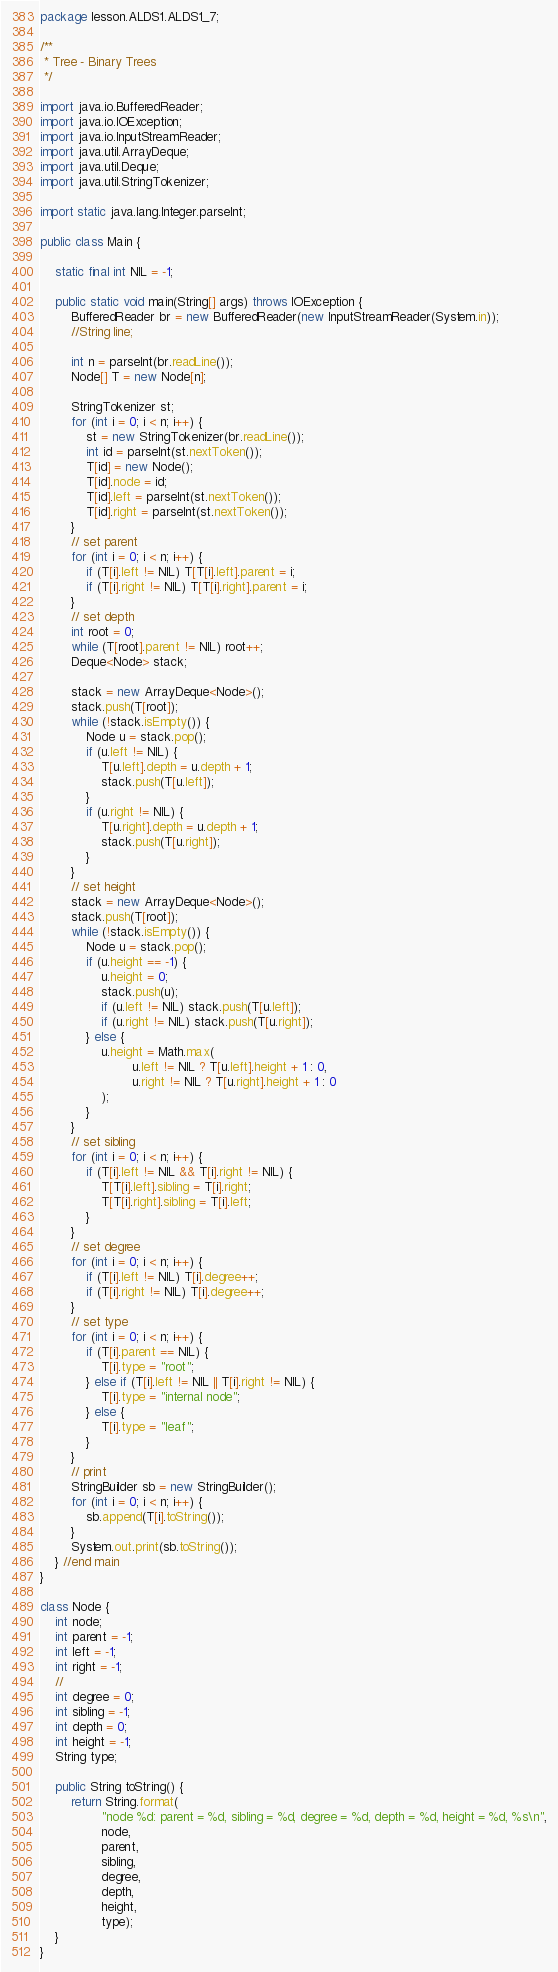<code> <loc_0><loc_0><loc_500><loc_500><_Java_>package lesson.ALDS1.ALDS1_7;

/**
 * Tree - Binary Trees
 */

import java.io.BufferedReader;
import java.io.IOException;
import java.io.InputStreamReader;
import java.util.ArrayDeque;
import java.util.Deque;
import java.util.StringTokenizer;

import static java.lang.Integer.parseInt;

public class Main {

	static final int NIL = -1;

	public static void main(String[] args) throws IOException {
		BufferedReader br = new BufferedReader(new InputStreamReader(System.in));
		//String line;

		int n = parseInt(br.readLine());
		Node[] T = new Node[n];

		StringTokenizer st;
		for (int i = 0; i < n; i++) {
			st = new StringTokenizer(br.readLine());
			int id = parseInt(st.nextToken());
			T[id] = new Node();
			T[id].node = id;
			T[id].left = parseInt(st.nextToken());
			T[id].right = parseInt(st.nextToken());
		}
		// set parent
		for (int i = 0; i < n; i++) {
			if (T[i].left != NIL) T[T[i].left].parent = i;
			if (T[i].right != NIL) T[T[i].right].parent = i;
		}
		// set depth
		int root = 0;
		while (T[root].parent != NIL) root++;
		Deque<Node> stack;

		stack = new ArrayDeque<Node>();
		stack.push(T[root]);
		while (!stack.isEmpty()) {
			Node u = stack.pop();
			if (u.left != NIL) {
				T[u.left].depth = u.depth + 1;
				stack.push(T[u.left]);
			}
			if (u.right != NIL) {
				T[u.right].depth = u.depth + 1;
				stack.push(T[u.right]);
			}
		}
		// set height
		stack = new ArrayDeque<Node>();
		stack.push(T[root]);
		while (!stack.isEmpty()) {
			Node u = stack.pop();
			if (u.height == -1) {
				u.height = 0;
				stack.push(u);
				if (u.left != NIL) stack.push(T[u.left]);
				if (u.right != NIL) stack.push(T[u.right]);
			} else {
				u.height = Math.max(
						u.left != NIL ? T[u.left].height + 1 : 0,
						u.right != NIL ? T[u.right].height + 1 : 0
				);
			}
		}
		// set sibling
		for (int i = 0; i < n; i++) {
			if (T[i].left != NIL && T[i].right != NIL) {
				T[T[i].left].sibling = T[i].right;
				T[T[i].right].sibling = T[i].left;
			}
		}
		// set degree
		for (int i = 0; i < n; i++) {
			if (T[i].left != NIL) T[i].degree++;
			if (T[i].right != NIL) T[i].degree++;
		}
		// set type
		for (int i = 0; i < n; i++) {
			if (T[i].parent == NIL) {
				T[i].type = "root";
			} else if (T[i].left != NIL || T[i].right != NIL) {
				T[i].type = "internal node";
			} else {
				T[i].type = "leaf";
			}
		}
		// print
		StringBuilder sb = new StringBuilder();
		for (int i = 0; i < n; i++) {
			sb.append(T[i].toString());
		}
		System.out.print(sb.toString());
	} //end main
}

class Node {
	int node;
	int parent = -1;
	int left = -1;
	int right = -1;
	//
	int degree = 0;
	int sibling = -1;
	int depth = 0;
	int height = -1;
	String type;

	public String toString() {
		return String.format(
				"node %d: parent = %d, sibling = %d, degree = %d, depth = %d, height = %d, %s\n",
				node,
				parent,
				sibling,
				degree,
				depth,
				height,
				type);
	}
}</code> 